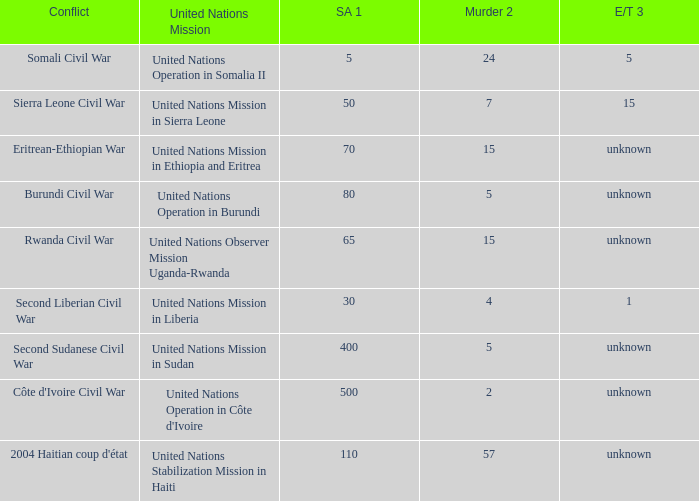What is the sexual abuse rate where the conflict is the Burundi Civil War? 80.0. 